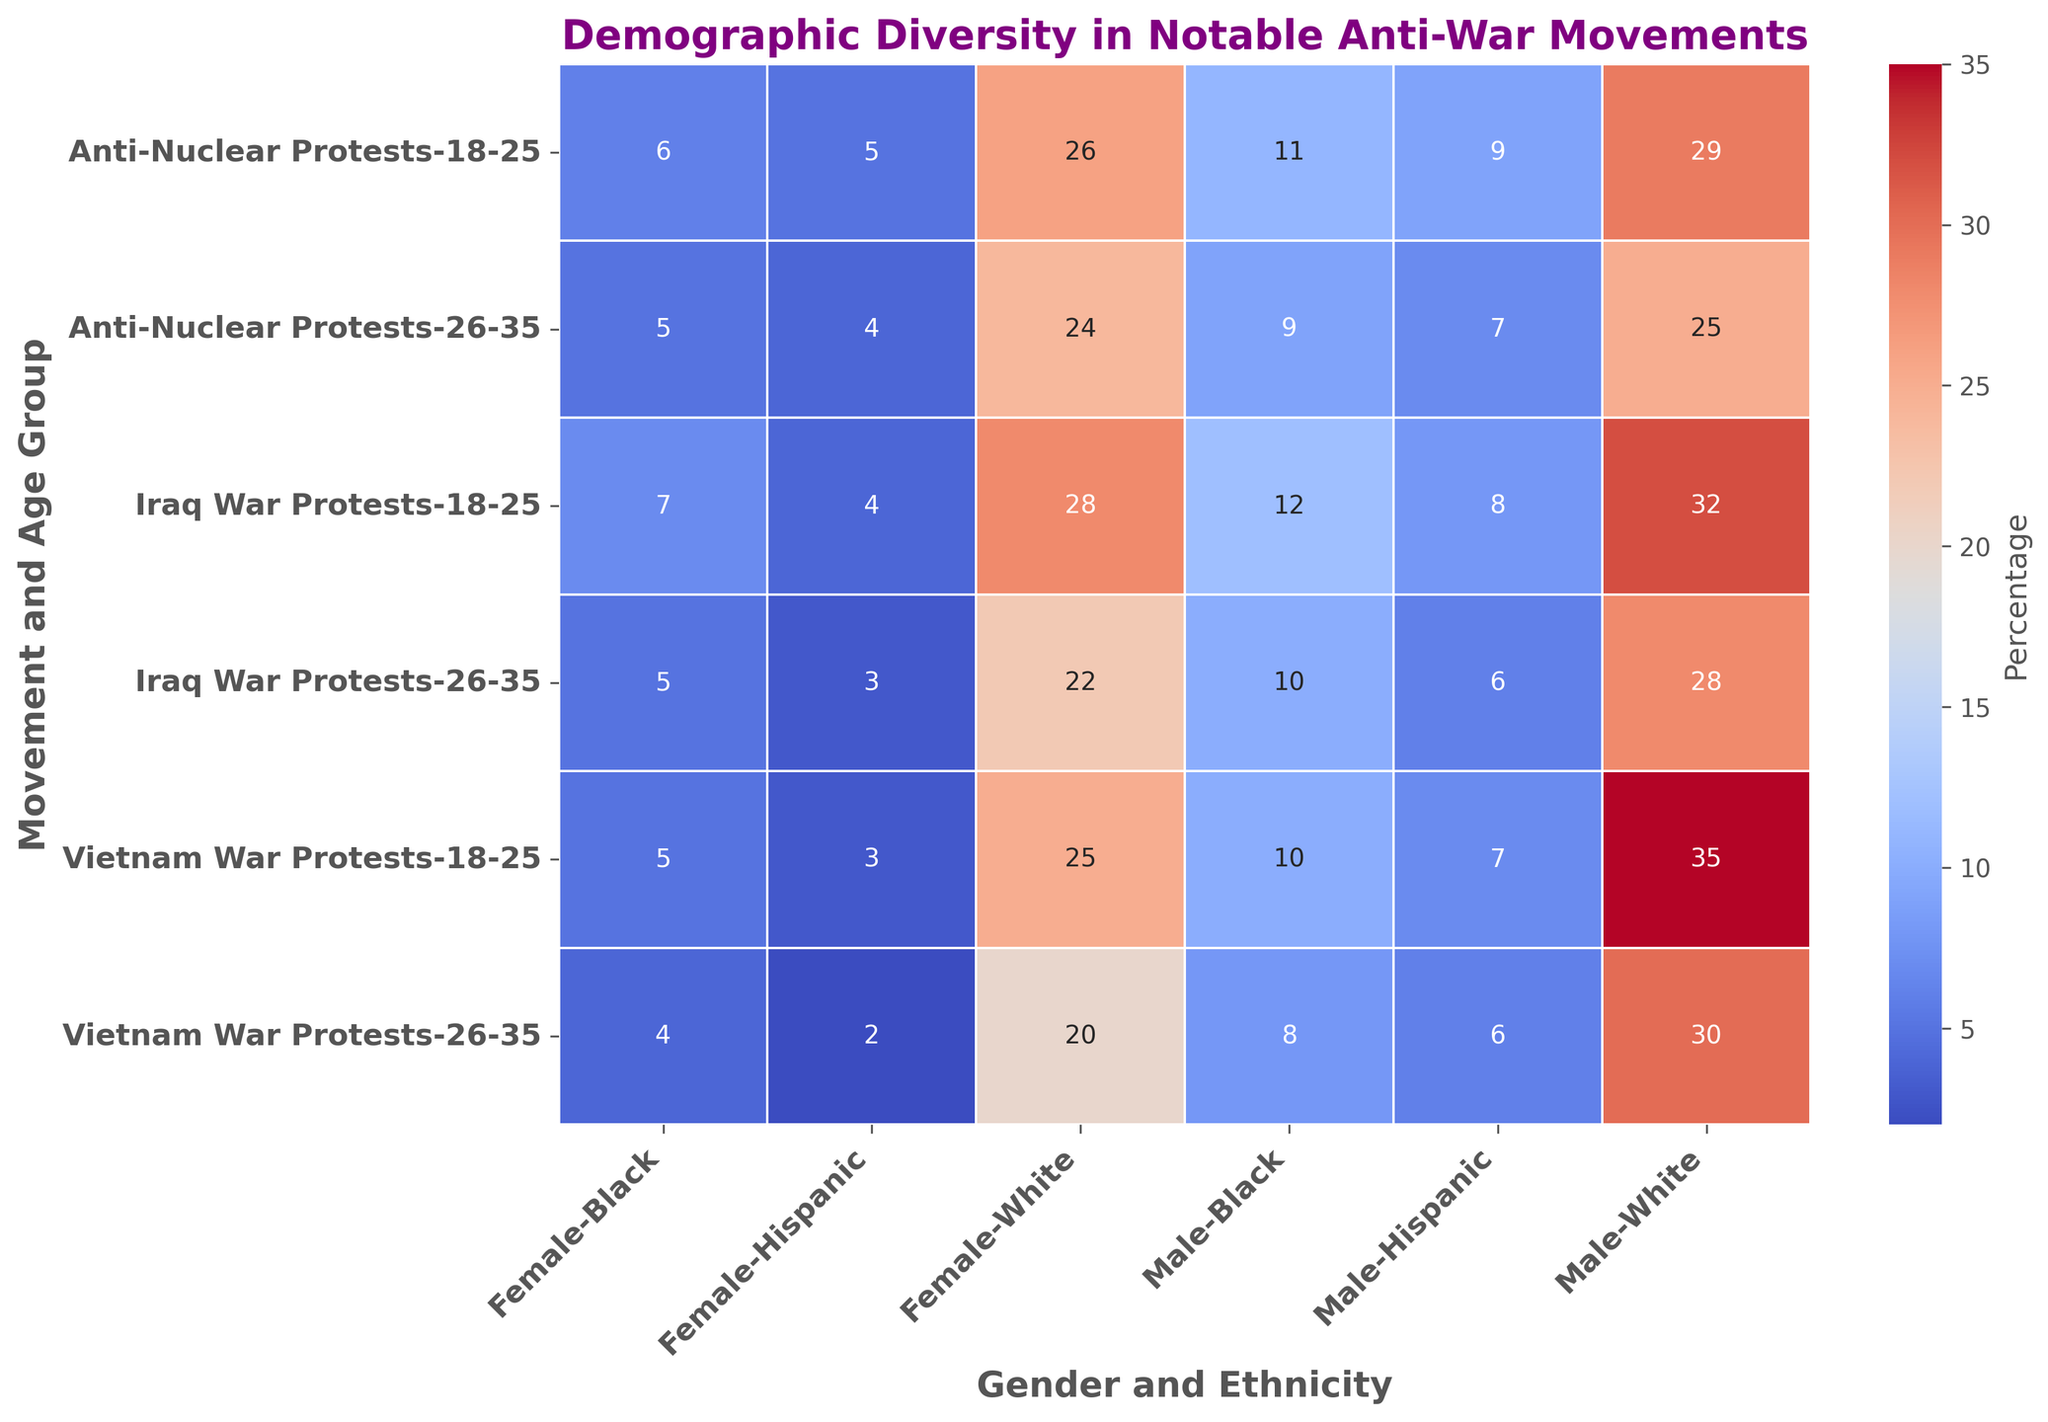Which protest has the highest representation of 26-35 year old males of White ethnicity? The heatmap shows the highest percentage in this category under the Vietnam War Protests, with 30%.
Answer: Vietnam War Protests How does the percentage of 18-25 year old Black females compare between the Vietnam War Protests and the Iraq War Protests? For the Vietnam War Protests, the percentage is 5%. For the Iraq War Protests, it is 7%. Thus, the Iraq War Protests have a higher percentage by 2%.
Answer: Iraq War Protests have a higher percentage What is the combined percentage of 18-25 year old participants of White ethnicity, regardless of gender, in the Anti-Nuclear Protests? Adding the percentages for 18-25 year old White males (29%) and females (26%), we get 29 + 26 = 55%.
Answer: 55% Which movement has the lowest representation of 26-35 year old Hispanic females? The heatmap indicates that both the Vietnam War Protests and the Iraq War Protests have the lowest representation, with 2% each.
Answer: Vietnam War Protests and Iraq War Protests In the Iraq War Protests, how does the gender distribution of 18-25 year old participants of Hispanic ethnicity compare? The percentage for males is 8%, while for females it's 4%. Therefore, males have double the representation of females in this category.
Answer: Males have double the representation Which age group and ethnicity combination has the nearest equal gender balance in the Anti-Nuclear Protests for 26-35 year olds? For 26-35 year olds in the Anti-Nuclear Protests, White ethnicity has almost equal representation with 25% for males and 24% for females.
Answer: White ethnicity What is the percentage difference between 26-35 year old Black males in Vietnam War Protests and Iraq War Protests? In the Vietnam War Protests, the percentage is 8%, and in the Iraq War Protests, it is 10%. The difference is 10 - 8 = 2%.
Answer: 2% Which protest has the most balanced representation (closest percentage) between males and females of Hispanic ethnicity within the 18-25 age group? The Anti-Nuclear Protests have 9% for males and 5% for females, which is the closest balance compared to other movements' larger disparities.
Answer: Anti-Nuclear Protests 